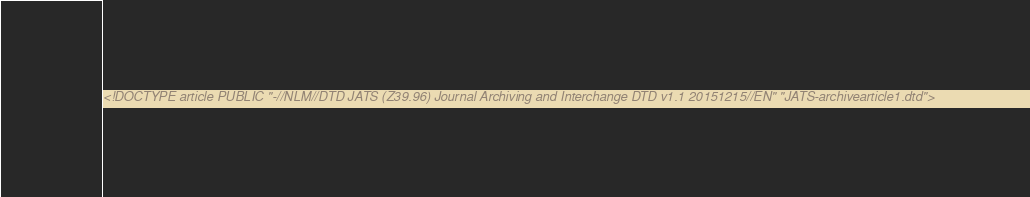Convert code to text. <code><loc_0><loc_0><loc_500><loc_500><_XML_><!DOCTYPE article PUBLIC "-//NLM//DTD JATS (Z39.96) Journal Archiving and Interchange DTD v1.1 20151215//EN" "JATS-archivearticle1.dtd"> </code> 